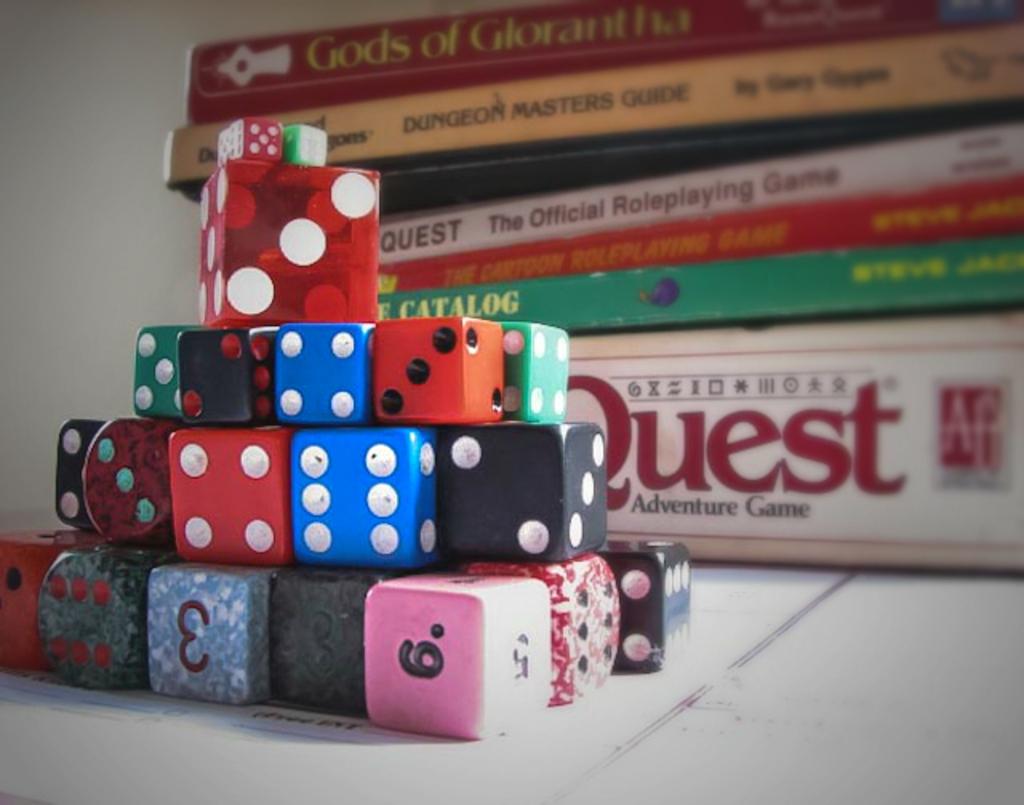Is quest a board game?
Your response must be concise. No. 